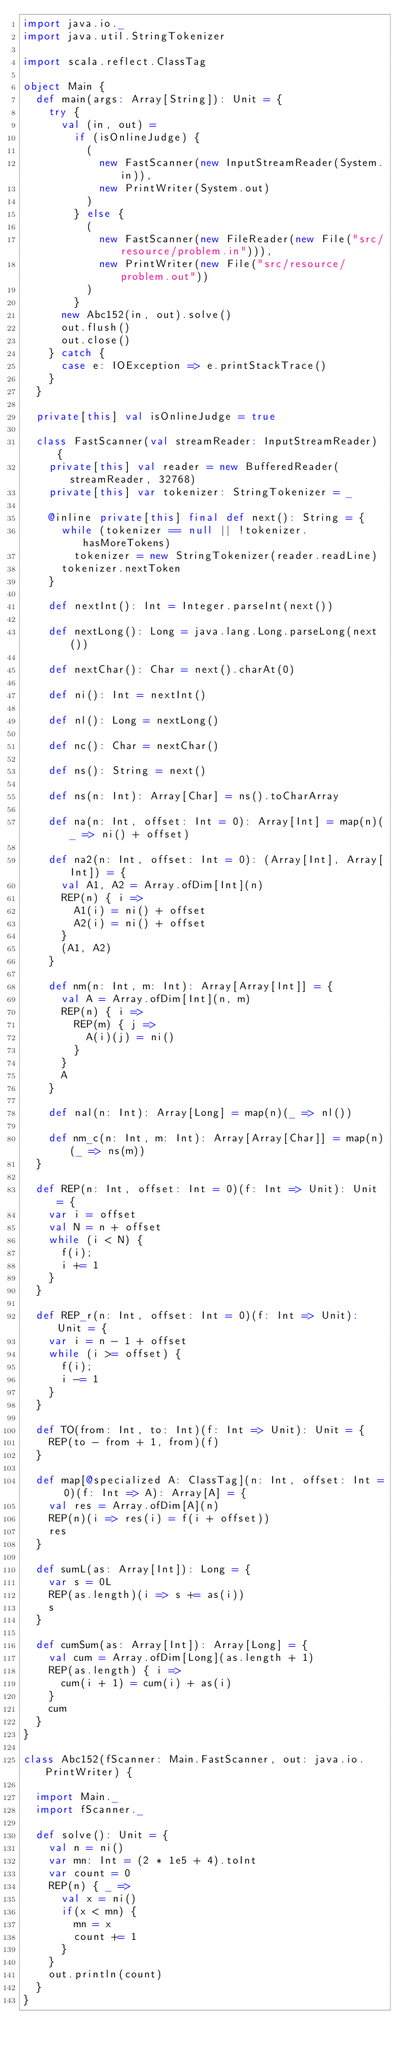Convert code to text. <code><loc_0><loc_0><loc_500><loc_500><_Scala_>import java.io._
import java.util.StringTokenizer

import scala.reflect.ClassTag

object Main {
  def main(args: Array[String]): Unit = {
    try {
      val (in, out) =
        if (isOnlineJudge) {
          (
            new FastScanner(new InputStreamReader(System.in)),
            new PrintWriter(System.out)
          )
        } else {
          (
            new FastScanner(new FileReader(new File("src/resource/problem.in"))),
            new PrintWriter(new File("src/resource/problem.out"))
          )
        }
      new Abc152(in, out).solve()
      out.flush()
      out.close()
    } catch {
      case e: IOException => e.printStackTrace()
    }
  }

  private[this] val isOnlineJudge = true

  class FastScanner(val streamReader: InputStreamReader) {
    private[this] val reader = new BufferedReader(streamReader, 32768)
    private[this] var tokenizer: StringTokenizer = _

    @inline private[this] final def next(): String = {
      while (tokenizer == null || !tokenizer.hasMoreTokens)
        tokenizer = new StringTokenizer(reader.readLine)
      tokenizer.nextToken
    }

    def nextInt(): Int = Integer.parseInt(next())

    def nextLong(): Long = java.lang.Long.parseLong(next())

    def nextChar(): Char = next().charAt(0)

    def ni(): Int = nextInt()

    def nl(): Long = nextLong()

    def nc(): Char = nextChar()

    def ns(): String = next()

    def ns(n: Int): Array[Char] = ns().toCharArray

    def na(n: Int, offset: Int = 0): Array[Int] = map(n)(_ => ni() + offset)

    def na2(n: Int, offset: Int = 0): (Array[Int], Array[Int]) = {
      val A1, A2 = Array.ofDim[Int](n)
      REP(n) { i =>
        A1(i) = ni() + offset
        A2(i) = ni() + offset
      }
      (A1, A2)
    }

    def nm(n: Int, m: Int): Array[Array[Int]] = {
      val A = Array.ofDim[Int](n, m)
      REP(n) { i =>
        REP(m) { j =>
          A(i)(j) = ni()
        }
      }
      A
    }

    def nal(n: Int): Array[Long] = map(n)(_ => nl())

    def nm_c(n: Int, m: Int): Array[Array[Char]] = map(n)(_ => ns(m))
  }

  def REP(n: Int, offset: Int = 0)(f: Int => Unit): Unit = {
    var i = offset
    val N = n + offset
    while (i < N) {
      f(i);
      i += 1
    }
  }

  def REP_r(n: Int, offset: Int = 0)(f: Int => Unit): Unit = {
    var i = n - 1 + offset
    while (i >= offset) {
      f(i);
      i -= 1
    }
  }

  def TO(from: Int, to: Int)(f: Int => Unit): Unit = {
    REP(to - from + 1, from)(f)
  }

  def map[@specialized A: ClassTag](n: Int, offset: Int = 0)(f: Int => A): Array[A] = {
    val res = Array.ofDim[A](n)
    REP(n)(i => res(i) = f(i + offset))
    res
  }

  def sumL(as: Array[Int]): Long = {
    var s = 0L
    REP(as.length)(i => s += as(i))
    s
  }

  def cumSum(as: Array[Int]): Array[Long] = {
    val cum = Array.ofDim[Long](as.length + 1)
    REP(as.length) { i =>
      cum(i + 1) = cum(i) + as(i)
    }
    cum
  }
}

class Abc152(fScanner: Main.FastScanner, out: java.io.PrintWriter) {

  import Main._
  import fScanner._

  def solve(): Unit = {
    val n = ni()
    var mn: Int = (2 * 1e5 + 4).toInt
    var count = 0
    REP(n) { _ =>
      val x = ni()
      if(x < mn) {
        mn = x
        count += 1
      }
    }
    out.println(count)
  }
}
</code> 